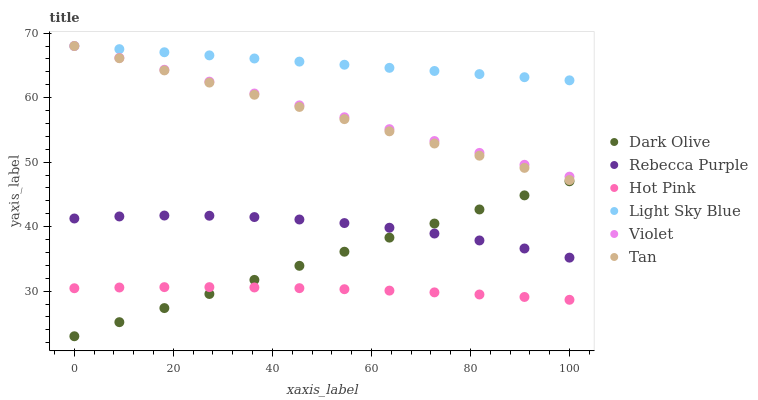Does Hot Pink have the minimum area under the curve?
Answer yes or no. Yes. Does Light Sky Blue have the maximum area under the curve?
Answer yes or no. Yes. Does Dark Olive have the minimum area under the curve?
Answer yes or no. No. Does Dark Olive have the maximum area under the curve?
Answer yes or no. No. Is Light Sky Blue the smoothest?
Answer yes or no. Yes. Is Rebecca Purple the roughest?
Answer yes or no. Yes. Is Dark Olive the smoothest?
Answer yes or no. No. Is Dark Olive the roughest?
Answer yes or no. No. Does Dark Olive have the lowest value?
Answer yes or no. Yes. Does Light Sky Blue have the lowest value?
Answer yes or no. No. Does Tan have the highest value?
Answer yes or no. Yes. Does Dark Olive have the highest value?
Answer yes or no. No. Is Rebecca Purple less than Light Sky Blue?
Answer yes or no. Yes. Is Light Sky Blue greater than Hot Pink?
Answer yes or no. Yes. Does Dark Olive intersect Rebecca Purple?
Answer yes or no. Yes. Is Dark Olive less than Rebecca Purple?
Answer yes or no. No. Is Dark Olive greater than Rebecca Purple?
Answer yes or no. No. Does Rebecca Purple intersect Light Sky Blue?
Answer yes or no. No. 